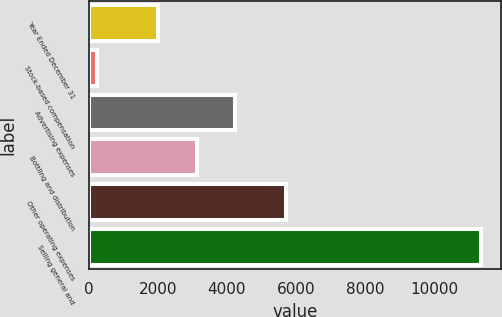Convert chart to OTSL. <chart><loc_0><loc_0><loc_500><loc_500><bar_chart><fcel>Year Ended December 31<fcel>Stock-based compensation<fcel>Advertising expenses<fcel>Bottling and distribution<fcel>Other operating expenses<fcel>Selling general and<nl><fcel>2009<fcel>241<fcel>4232.4<fcel>3120.7<fcel>5699<fcel>11358<nl></chart> 